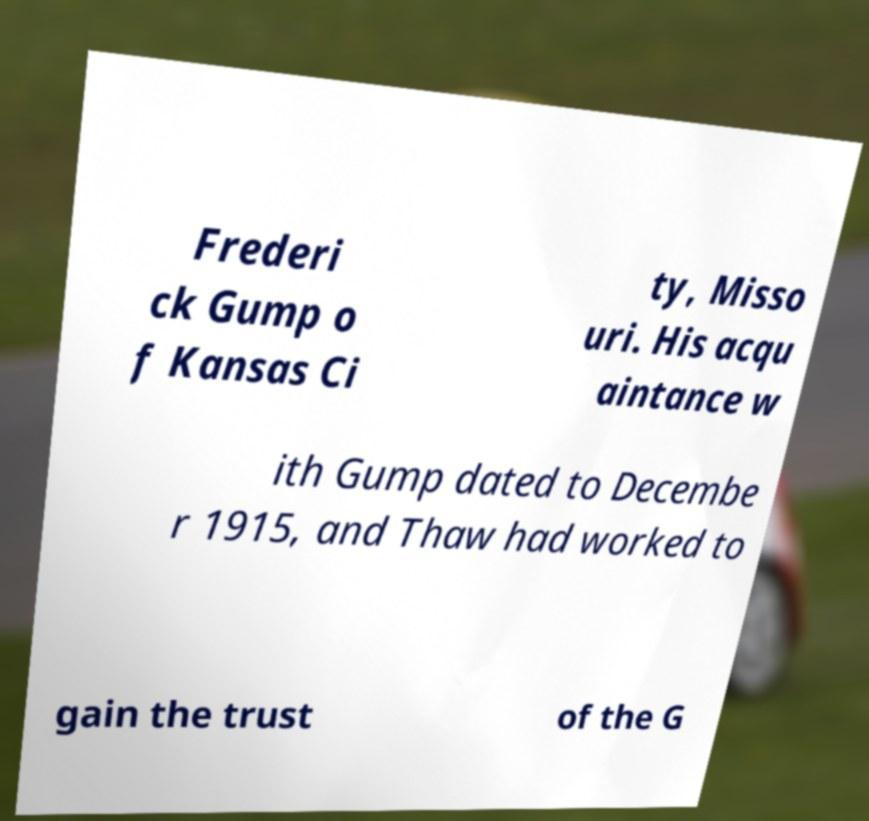Please identify and transcribe the text found in this image. Frederi ck Gump o f Kansas Ci ty, Misso uri. His acqu aintance w ith Gump dated to Decembe r 1915, and Thaw had worked to gain the trust of the G 